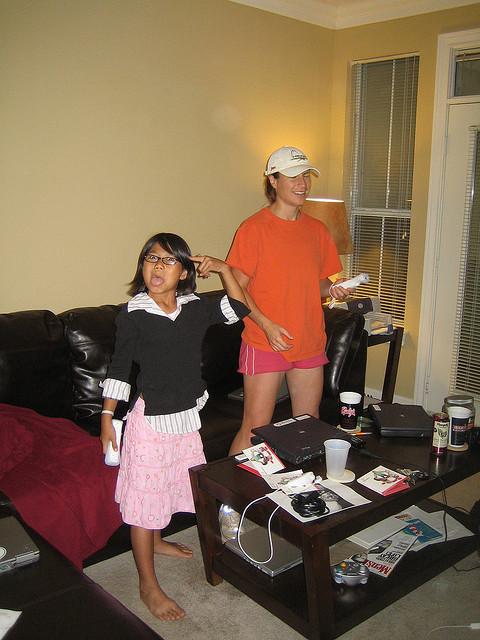What is the couch made of?
Answer briefly. Leather. What device is in the right person's left hand?
Write a very short answer. Wii remote. Is the woman wearing stockings in the image?
Concise answer only. No. What is the woman holding?
Short answer required. Wii remote. Is one person taller than the other?
Quick response, please. Yes. How many cups are on the coffee table?
Quick response, please. 3. 